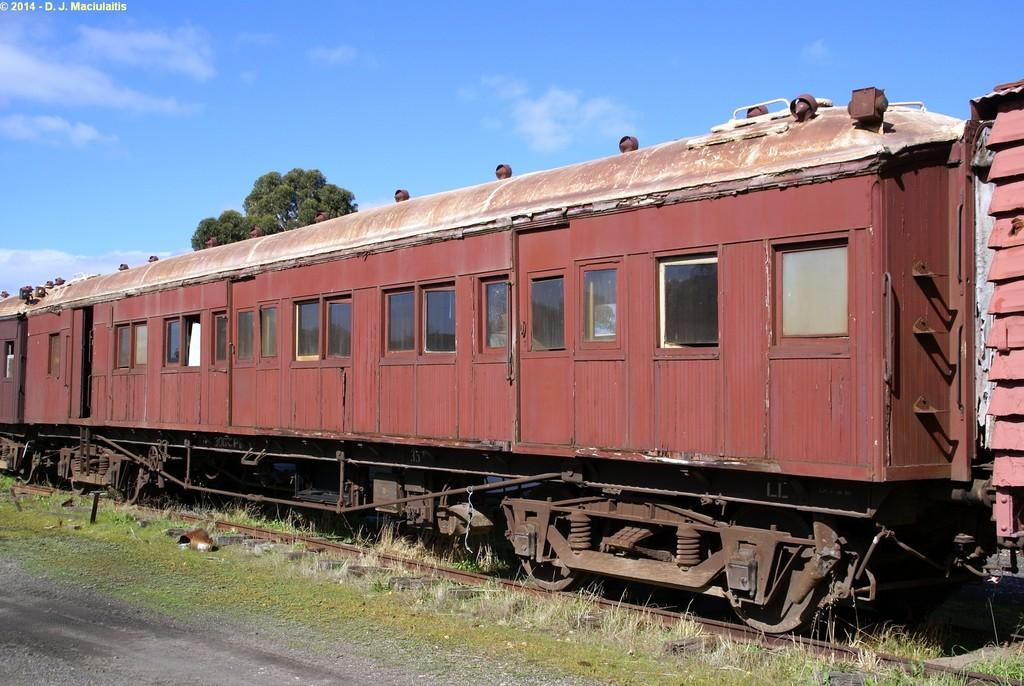What is the main subject of the image? There is a train in the image. Where is the train located? The train is on a railway track. What type of vegetation can be seen in the image? There is grass and trees visible in the image. What is the color of the sky in the image? The sky is blue in the image. How much wealth is represented by the train in the image? The image does not provide any information about the wealth or value of the train. What type of cloud can be seen in the image? There are no clouds visible in the image; the sky is described as blue. 